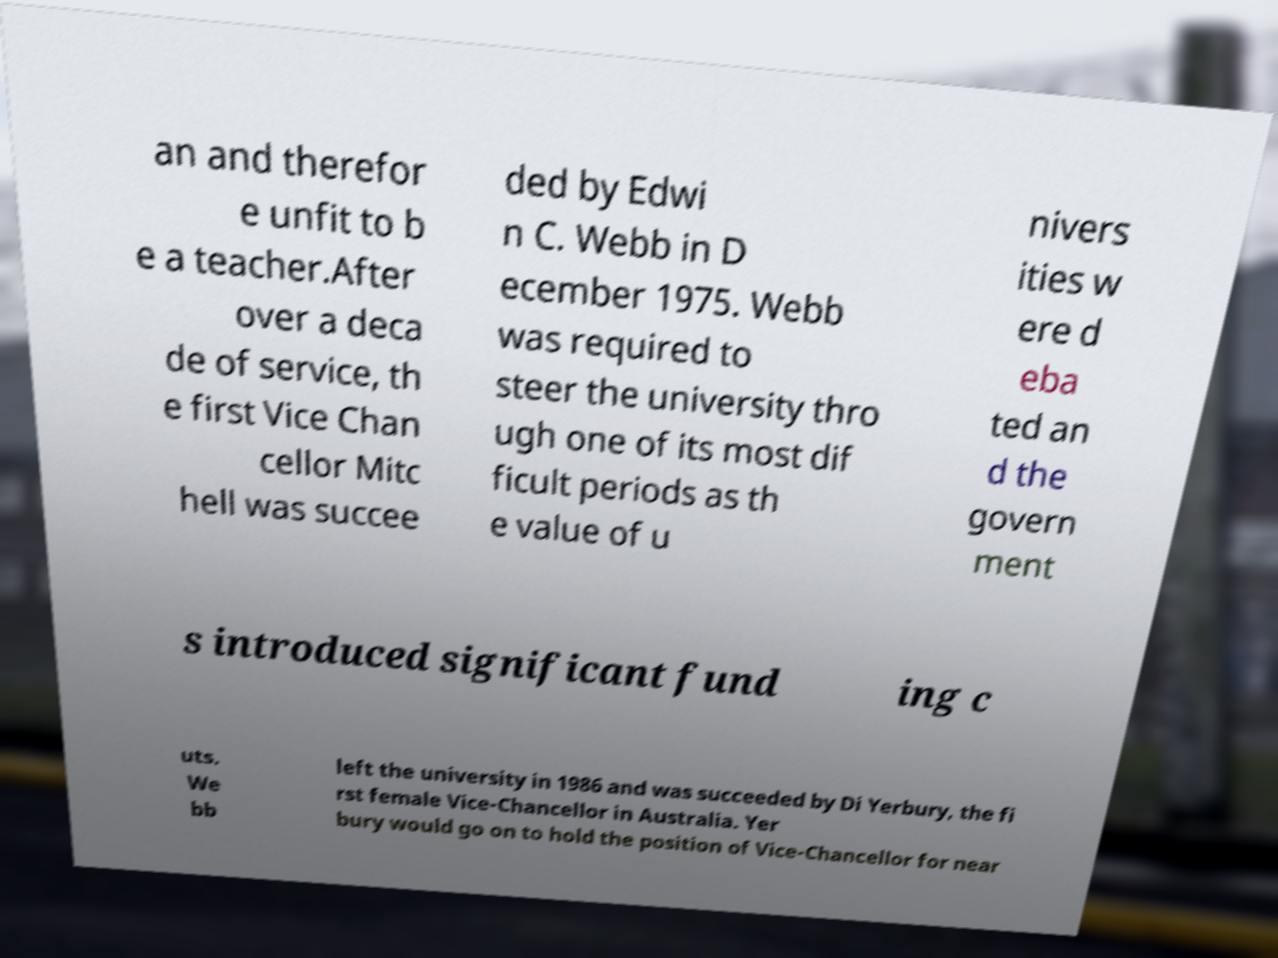There's text embedded in this image that I need extracted. Can you transcribe it verbatim? an and therefor e unfit to b e a teacher.After over a deca de of service, th e first Vice Chan cellor Mitc hell was succee ded by Edwi n C. Webb in D ecember 1975. Webb was required to steer the university thro ugh one of its most dif ficult periods as th e value of u nivers ities w ere d eba ted an d the govern ment s introduced significant fund ing c uts. We bb left the university in 1986 and was succeeded by Di Yerbury, the fi rst female Vice-Chancellor in Australia. Yer bury would go on to hold the position of Vice-Chancellor for near 